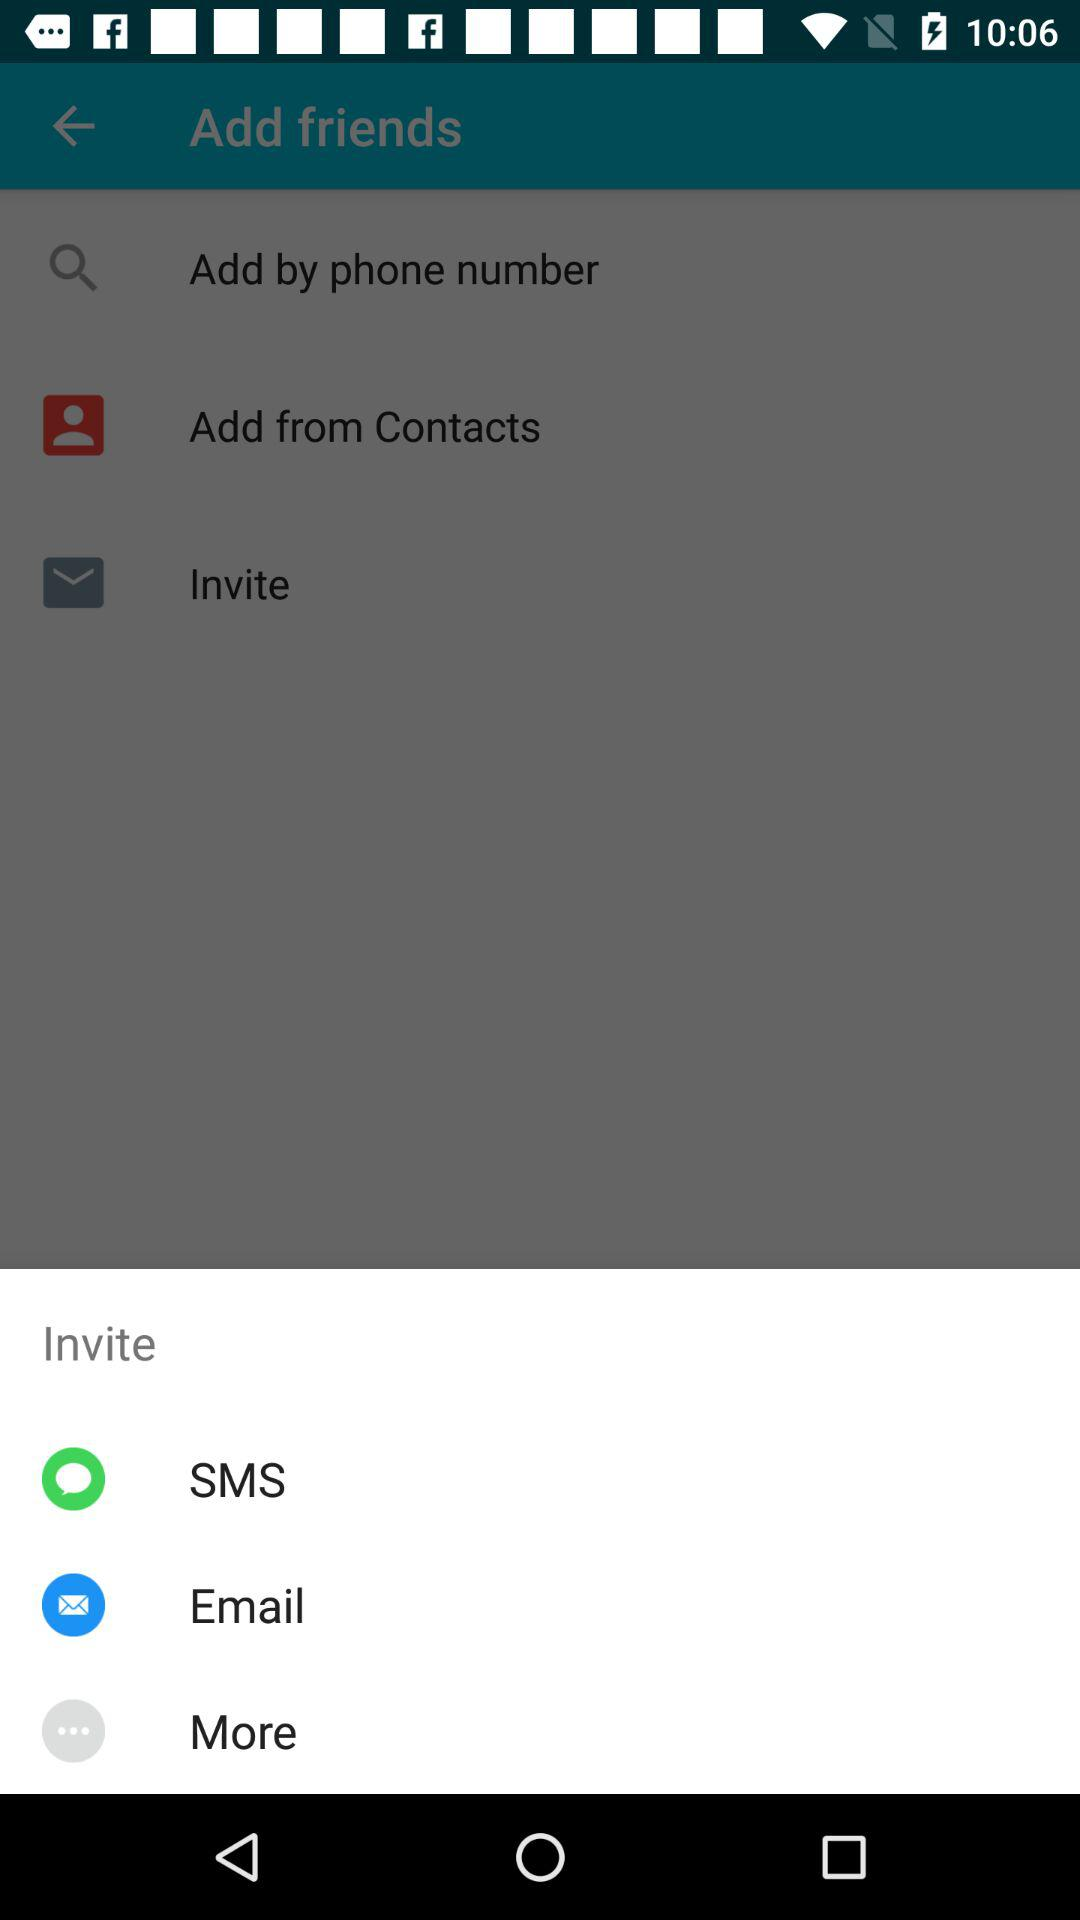What are the options to invite? The options to invite are "SMS" and "EMAIL". 